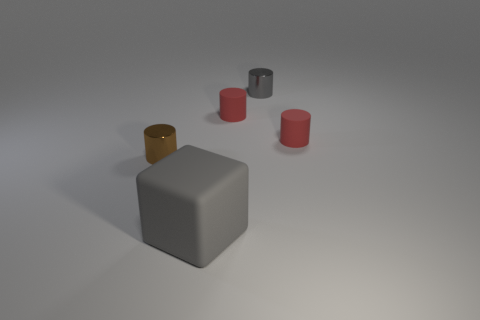Subtract all brown cylinders. How many cylinders are left? 3 Subtract all gray metal cylinders. How many cylinders are left? 3 Subtract all yellow cylinders. Subtract all blue cubes. How many cylinders are left? 4 Add 4 small gray cubes. How many objects exist? 9 Subtract all cylinders. How many objects are left? 1 Subtract all brown cylinders. Subtract all small gray shiny cylinders. How many objects are left? 3 Add 2 large matte things. How many large matte things are left? 3 Add 5 small red objects. How many small red objects exist? 7 Subtract 0 purple blocks. How many objects are left? 5 